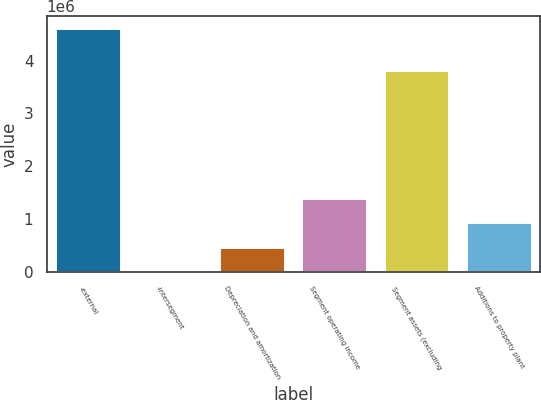Convert chart to OTSL. <chart><loc_0><loc_0><loc_500><loc_500><bar_chart><fcel>-external<fcel>-intersegment<fcel>Depreciation and amortization<fcel>Segment operating income<fcel>Segment assets (excluding<fcel>Additions to property plant<nl><fcel>4.61467e+06<fcel>24911<fcel>483887<fcel>1.40184e+06<fcel>3.81335e+06<fcel>942863<nl></chart> 